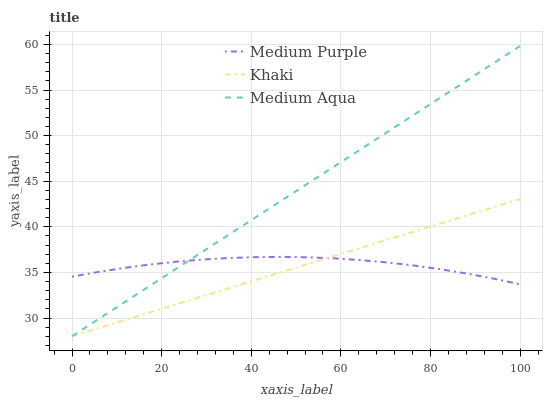Does Khaki have the minimum area under the curve?
Answer yes or no. Yes. Does Medium Aqua have the maximum area under the curve?
Answer yes or no. Yes. Does Medium Aqua have the minimum area under the curve?
Answer yes or no. No. Does Khaki have the maximum area under the curve?
Answer yes or no. No. Is Khaki the smoothest?
Answer yes or no. Yes. Is Medium Purple the roughest?
Answer yes or no. Yes. Is Medium Aqua the smoothest?
Answer yes or no. No. Is Medium Aqua the roughest?
Answer yes or no. No. Does Khaki have the lowest value?
Answer yes or no. Yes. Does Medium Aqua have the highest value?
Answer yes or no. Yes. Does Khaki have the highest value?
Answer yes or no. No. Does Medium Aqua intersect Medium Purple?
Answer yes or no. Yes. Is Medium Aqua less than Medium Purple?
Answer yes or no. No. Is Medium Aqua greater than Medium Purple?
Answer yes or no. No. 